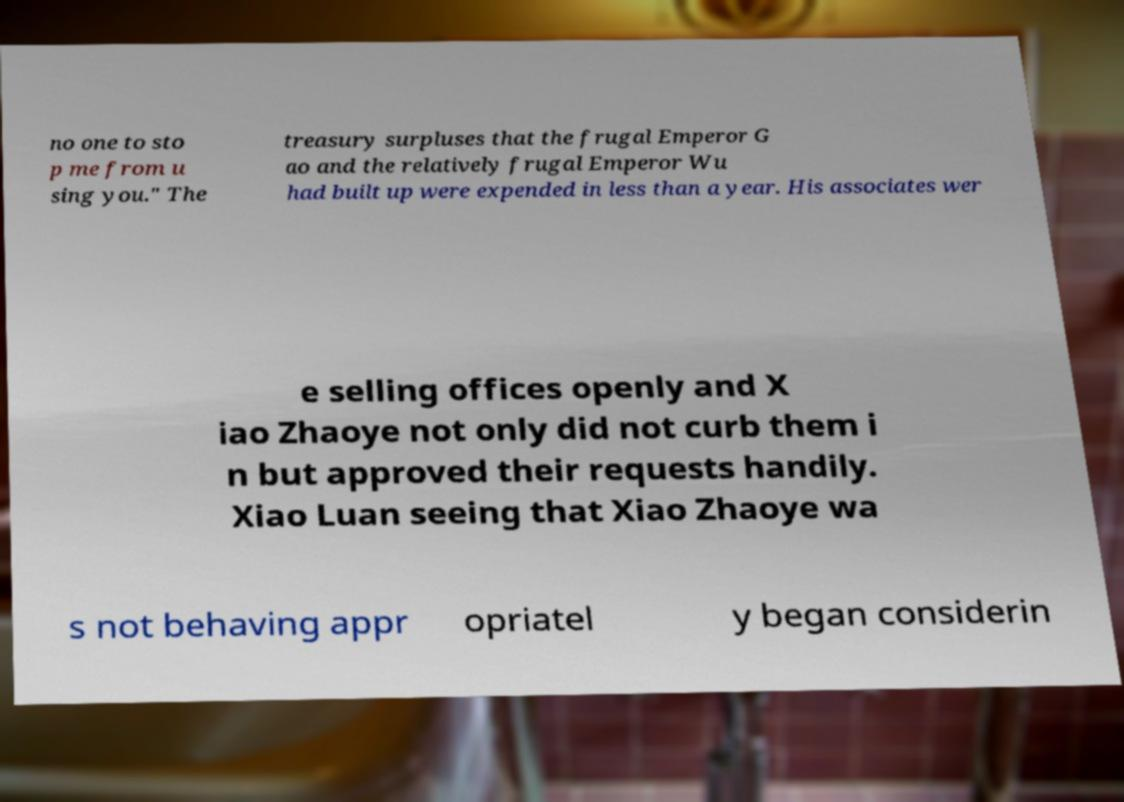Can you read and provide the text displayed in the image?This photo seems to have some interesting text. Can you extract and type it out for me? no one to sto p me from u sing you." The treasury surpluses that the frugal Emperor G ao and the relatively frugal Emperor Wu had built up were expended in less than a year. His associates wer e selling offices openly and X iao Zhaoye not only did not curb them i n but approved their requests handily. Xiao Luan seeing that Xiao Zhaoye wa s not behaving appr opriatel y began considerin 